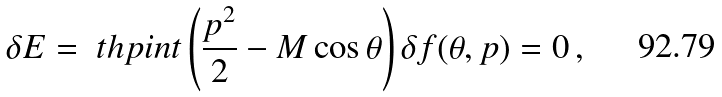Convert formula to latex. <formula><loc_0><loc_0><loc_500><loc_500>\delta E = \ t h p i n t \left ( \frac { p ^ { 2 } } { 2 } - M \cos \theta \right ) \delta f ( \theta , p ) = 0 \, ,</formula> 